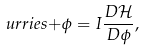Convert formula to latex. <formula><loc_0><loc_0><loc_500><loc_500>\ u r r i e s { + } \phi = I \frac { D \mathcal { H } } { D \phi } ,</formula> 